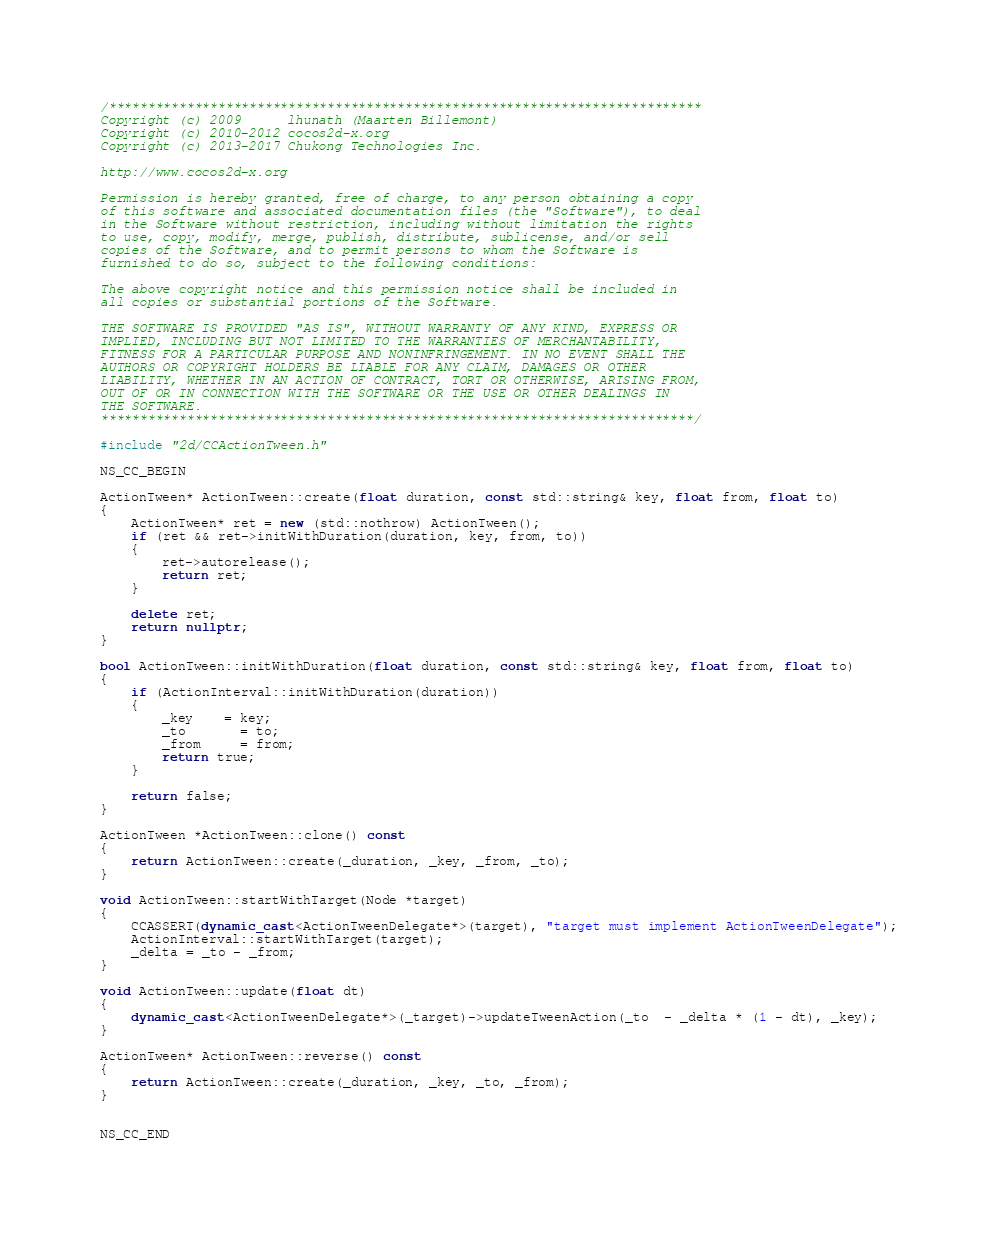<code> <loc_0><loc_0><loc_500><loc_500><_C++_>/****************************************************************************
Copyright (c) 2009      lhunath (Maarten Billemont)
Copyright (c) 2010-2012 cocos2d-x.org
Copyright (c) 2013-2017 Chukong Technologies Inc.
 
http://www.cocos2d-x.org

Permission is hereby granted, free of charge, to any person obtaining a copy
of this software and associated documentation files (the "Software"), to deal
in the Software without restriction, including without limitation the rights
to use, copy, modify, merge, publish, distribute, sublicense, and/or sell
copies of the Software, and to permit persons to whom the Software is
furnished to do so, subject to the following conditions:

The above copyright notice and this permission notice shall be included in
all copies or substantial portions of the Software.

THE SOFTWARE IS PROVIDED "AS IS", WITHOUT WARRANTY OF ANY KIND, EXPRESS OR
IMPLIED, INCLUDING BUT NOT LIMITED TO THE WARRANTIES OF MERCHANTABILITY,
FITNESS FOR A PARTICULAR PURPOSE AND NONINFRINGEMENT. IN NO EVENT SHALL THE
AUTHORS OR COPYRIGHT HOLDERS BE LIABLE FOR ANY CLAIM, DAMAGES OR OTHER
LIABILITY, WHETHER IN AN ACTION OF CONTRACT, TORT OR OTHERWISE, ARISING FROM,
OUT OF OR IN CONNECTION WITH THE SOFTWARE OR THE USE OR OTHER DEALINGS IN
THE SOFTWARE.
****************************************************************************/

#include "2d/CCActionTween.h"

NS_CC_BEGIN

ActionTween* ActionTween::create(float duration, const std::string& key, float from, float to)
{
    ActionTween* ret = new (std::nothrow) ActionTween();
    if (ret && ret->initWithDuration(duration, key, from, to))
    {
        ret->autorelease();
        return ret;
    }
    
    delete ret;
    return nullptr;
}

bool ActionTween::initWithDuration(float duration, const std::string& key, float from, float to)
{
    if (ActionInterval::initWithDuration(duration))
    {
        _key    = key;
        _to       = to;
        _from     = from;
        return true;
    }

    return false;
}

ActionTween *ActionTween::clone() const
{
    return ActionTween::create(_duration, _key, _from, _to);
}

void ActionTween::startWithTarget(Node *target)
{
    CCASSERT(dynamic_cast<ActionTweenDelegate*>(target), "target must implement ActionTweenDelegate");
    ActionInterval::startWithTarget(target);
    _delta = _to - _from;
}

void ActionTween::update(float dt)
{
    dynamic_cast<ActionTweenDelegate*>(_target)->updateTweenAction(_to  - _delta * (1 - dt), _key);
}

ActionTween* ActionTween::reverse() const
{
    return ActionTween::create(_duration, _key, _to, _from);
}


NS_CC_END
</code> 